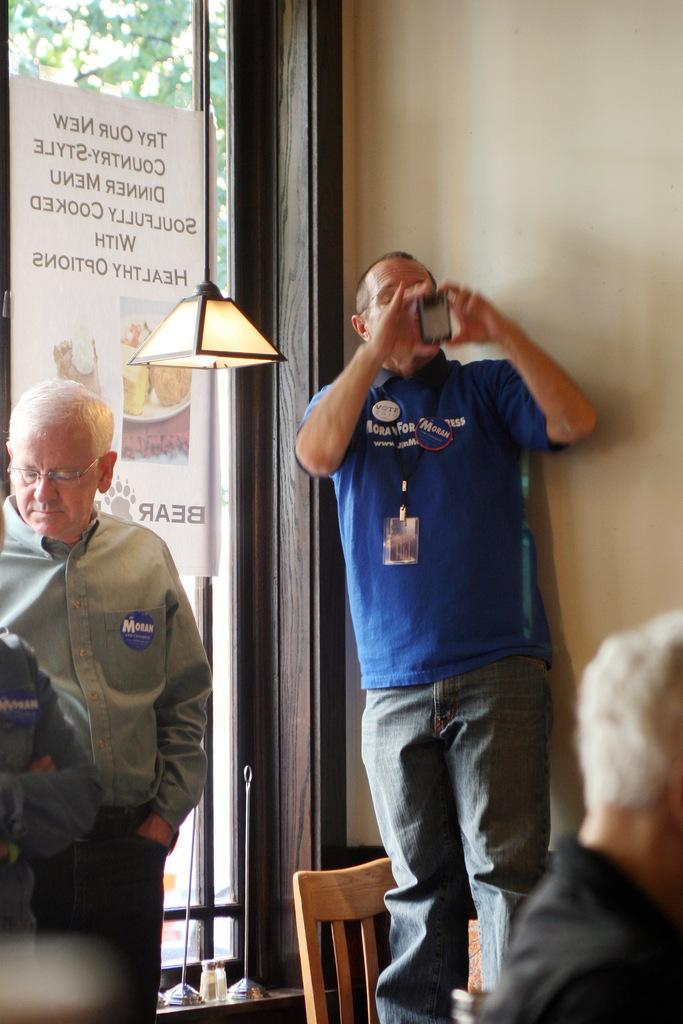What is the person in the blue shirt doing in the image? The person wearing a blue shirt is standing on a chair and clicking a picture. Can you describe the position of the person in the blue shirt? The person in the blue shirt is standing on a chair. Who else is present in the image? There is another person standing beside the person with the blue shirt. What type of frame is being used by the person in the blue shirt to take the picture? There is no frame mentioned or visible in the image; the person is simply clicking a picture. 